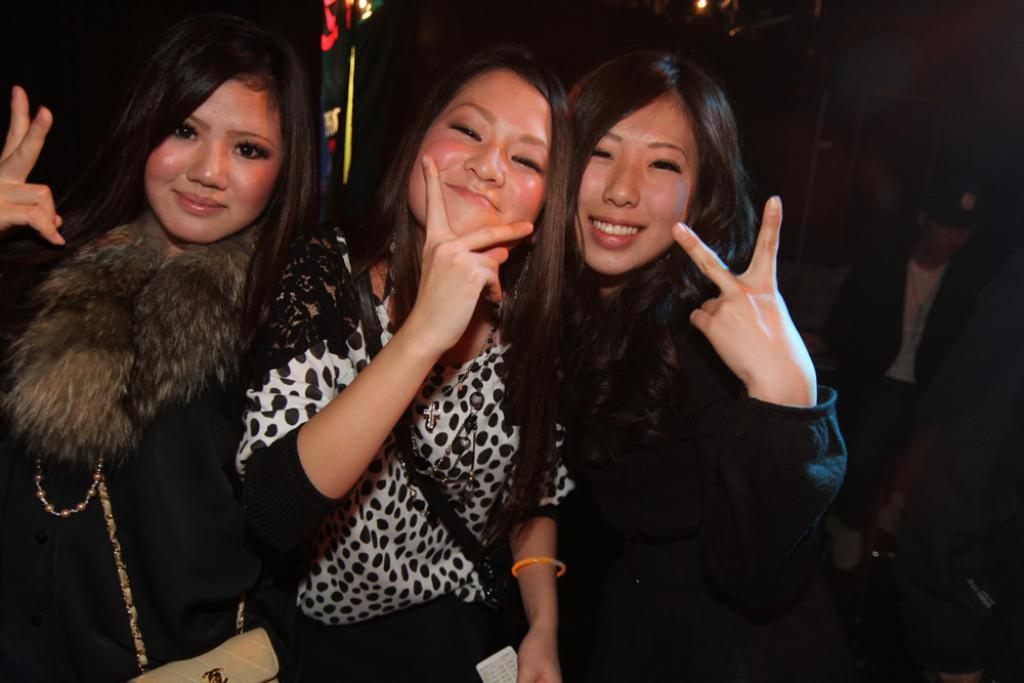How many women are in the image? There are three women in the image. What are the women wearing? The women are wearing black dresses. What action are the women performing in the image? The women are showing a peace symbol. What expression do the women have in the image? The women are smiling. What type of sponge is being used by the women to clean the floor in the image? There is no sponge or cleaning activity present in the image; the women are showing a peace symbol and smiling. 